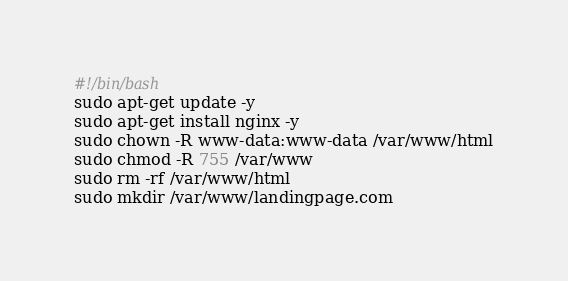Convert code to text. <code><loc_0><loc_0><loc_500><loc_500><_Bash_>#!/bin/bash
sudo apt-get update -y
sudo apt-get install nginx -y
sudo chown -R www-data:www-data /var/www/html
sudo chmod -R 755 /var/www
sudo rm -rf /var/www/html
sudo mkdir /var/www/landingpage.com
</code> 